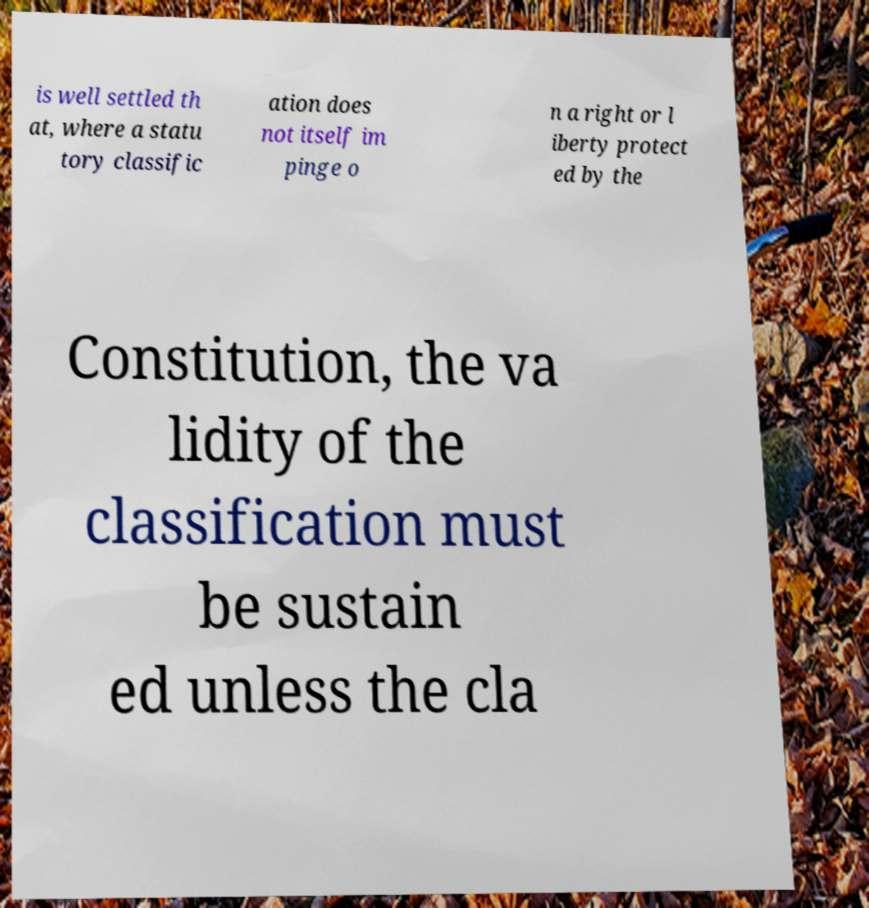Can you read and provide the text displayed in the image?This photo seems to have some interesting text. Can you extract and type it out for me? is well settled th at, where a statu tory classific ation does not itself im pinge o n a right or l iberty protect ed by the Constitution, the va lidity of the classification must be sustain ed unless the cla 